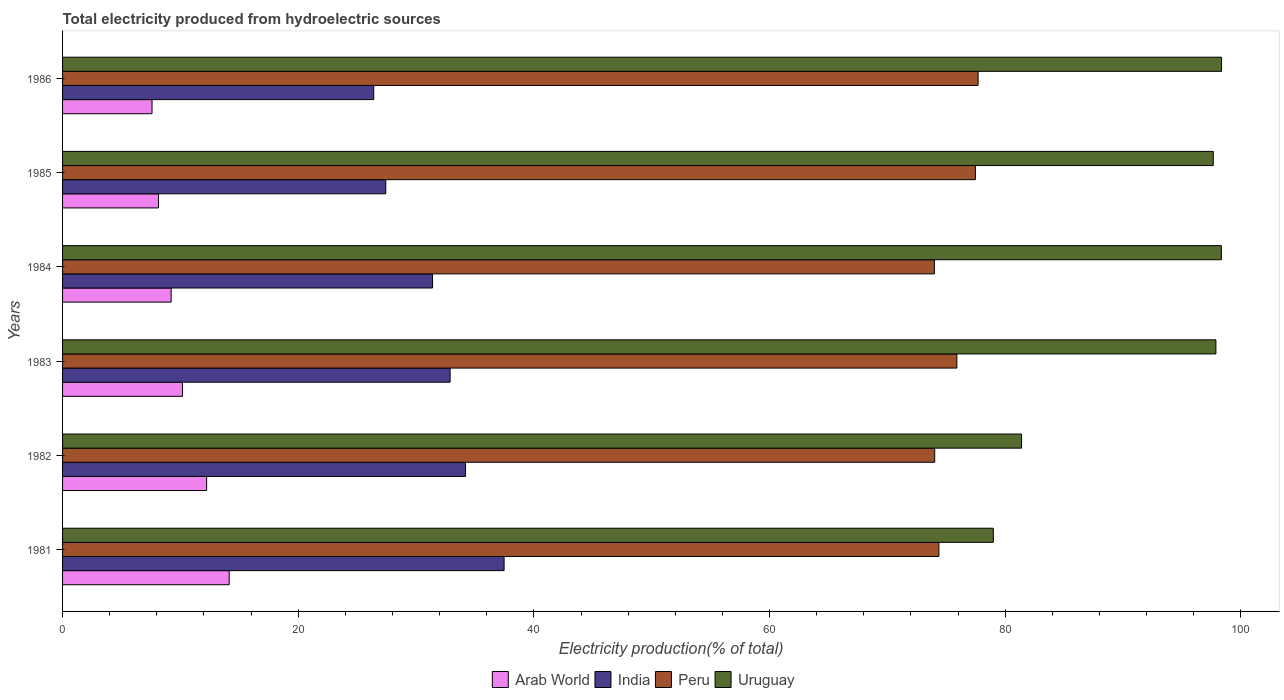How many different coloured bars are there?
Offer a terse response. 4. Are the number of bars per tick equal to the number of legend labels?
Offer a terse response. Yes. How many bars are there on the 1st tick from the top?
Give a very brief answer. 4. What is the total electricity produced in Peru in 1982?
Offer a very short reply. 74.01. Across all years, what is the maximum total electricity produced in Peru?
Provide a succinct answer. 77.7. Across all years, what is the minimum total electricity produced in Arab World?
Your answer should be very brief. 7.59. In which year was the total electricity produced in Uruguay minimum?
Your response must be concise. 1981. What is the total total electricity produced in India in the graph?
Make the answer very short. 189.79. What is the difference between the total electricity produced in India in 1983 and that in 1985?
Offer a very short reply. 5.46. What is the difference between the total electricity produced in India in 1985 and the total electricity produced in Uruguay in 1984?
Give a very brief answer. -70.91. What is the average total electricity produced in India per year?
Provide a succinct answer. 31.63. In the year 1984, what is the difference between the total electricity produced in Peru and total electricity produced in India?
Give a very brief answer. 42.59. What is the ratio of the total electricity produced in Arab World in 1981 to that in 1983?
Your answer should be compact. 1.39. Is the difference between the total electricity produced in Peru in 1982 and 1985 greater than the difference between the total electricity produced in India in 1982 and 1985?
Offer a terse response. No. What is the difference between the highest and the second highest total electricity produced in India?
Provide a succinct answer. 3.27. What is the difference between the highest and the lowest total electricity produced in Arab World?
Provide a succinct answer. 6.55. In how many years, is the total electricity produced in Peru greater than the average total electricity produced in Peru taken over all years?
Your answer should be compact. 3. Is it the case that in every year, the sum of the total electricity produced in Arab World and total electricity produced in India is greater than the sum of total electricity produced in Peru and total electricity produced in Uruguay?
Offer a terse response. No. Is it the case that in every year, the sum of the total electricity produced in Peru and total electricity produced in India is greater than the total electricity produced in Arab World?
Make the answer very short. Yes. What is the difference between two consecutive major ticks on the X-axis?
Provide a short and direct response. 20. Does the graph contain grids?
Your answer should be very brief. No. Where does the legend appear in the graph?
Your response must be concise. Bottom center. How are the legend labels stacked?
Provide a succinct answer. Horizontal. What is the title of the graph?
Your answer should be compact. Total electricity produced from hydroelectric sources. What is the Electricity production(% of total) in Arab World in 1981?
Offer a terse response. 14.14. What is the Electricity production(% of total) in India in 1981?
Provide a succinct answer. 37.47. What is the Electricity production(% of total) of Peru in 1981?
Make the answer very short. 74.37. What is the Electricity production(% of total) in Uruguay in 1981?
Ensure brevity in your answer.  78.99. What is the Electricity production(% of total) of Arab World in 1982?
Your answer should be compact. 12.23. What is the Electricity production(% of total) of India in 1982?
Give a very brief answer. 34.2. What is the Electricity production(% of total) in Peru in 1982?
Ensure brevity in your answer.  74.01. What is the Electricity production(% of total) of Uruguay in 1982?
Your answer should be compact. 81.38. What is the Electricity production(% of total) of Arab World in 1983?
Your answer should be very brief. 10.17. What is the Electricity production(% of total) of India in 1983?
Your answer should be compact. 32.89. What is the Electricity production(% of total) in Peru in 1983?
Your response must be concise. 75.89. What is the Electricity production(% of total) in Uruguay in 1983?
Offer a terse response. 97.88. What is the Electricity production(% of total) in Arab World in 1984?
Offer a very short reply. 9.22. What is the Electricity production(% of total) of India in 1984?
Provide a short and direct response. 31.4. What is the Electricity production(% of total) of Peru in 1984?
Give a very brief answer. 73.99. What is the Electricity production(% of total) in Uruguay in 1984?
Your response must be concise. 98.34. What is the Electricity production(% of total) of Arab World in 1985?
Keep it short and to the point. 8.14. What is the Electricity production(% of total) of India in 1985?
Make the answer very short. 27.43. What is the Electricity production(% of total) of Peru in 1985?
Make the answer very short. 77.47. What is the Electricity production(% of total) in Uruguay in 1985?
Keep it short and to the point. 97.65. What is the Electricity production(% of total) in Arab World in 1986?
Provide a short and direct response. 7.59. What is the Electricity production(% of total) in India in 1986?
Offer a very short reply. 26.41. What is the Electricity production(% of total) of Peru in 1986?
Offer a very short reply. 77.7. What is the Electricity production(% of total) of Uruguay in 1986?
Provide a succinct answer. 98.35. Across all years, what is the maximum Electricity production(% of total) of Arab World?
Make the answer very short. 14.14. Across all years, what is the maximum Electricity production(% of total) of India?
Ensure brevity in your answer.  37.47. Across all years, what is the maximum Electricity production(% of total) of Peru?
Provide a short and direct response. 77.7. Across all years, what is the maximum Electricity production(% of total) of Uruguay?
Give a very brief answer. 98.35. Across all years, what is the minimum Electricity production(% of total) in Arab World?
Ensure brevity in your answer.  7.59. Across all years, what is the minimum Electricity production(% of total) of India?
Your answer should be very brief. 26.41. Across all years, what is the minimum Electricity production(% of total) in Peru?
Your answer should be very brief. 73.99. Across all years, what is the minimum Electricity production(% of total) of Uruguay?
Your answer should be very brief. 78.99. What is the total Electricity production(% of total) of Arab World in the graph?
Your answer should be compact. 61.49. What is the total Electricity production(% of total) in India in the graph?
Offer a terse response. 189.79. What is the total Electricity production(% of total) in Peru in the graph?
Give a very brief answer. 453.42. What is the total Electricity production(% of total) of Uruguay in the graph?
Keep it short and to the point. 552.6. What is the difference between the Electricity production(% of total) of Arab World in 1981 and that in 1982?
Your response must be concise. 1.91. What is the difference between the Electricity production(% of total) of India in 1981 and that in 1982?
Make the answer very short. 3.27. What is the difference between the Electricity production(% of total) in Peru in 1981 and that in 1982?
Make the answer very short. 0.35. What is the difference between the Electricity production(% of total) in Uruguay in 1981 and that in 1982?
Offer a very short reply. -2.4. What is the difference between the Electricity production(% of total) in Arab World in 1981 and that in 1983?
Keep it short and to the point. 3.97. What is the difference between the Electricity production(% of total) of India in 1981 and that in 1983?
Your answer should be compact. 4.58. What is the difference between the Electricity production(% of total) in Peru in 1981 and that in 1983?
Provide a succinct answer. -1.53. What is the difference between the Electricity production(% of total) of Uruguay in 1981 and that in 1983?
Make the answer very short. -18.89. What is the difference between the Electricity production(% of total) of Arab World in 1981 and that in 1984?
Offer a very short reply. 4.93. What is the difference between the Electricity production(% of total) of India in 1981 and that in 1984?
Make the answer very short. 6.07. What is the difference between the Electricity production(% of total) in Peru in 1981 and that in 1984?
Keep it short and to the point. 0.38. What is the difference between the Electricity production(% of total) of Uruguay in 1981 and that in 1984?
Give a very brief answer. -19.35. What is the difference between the Electricity production(% of total) in Arab World in 1981 and that in 1985?
Make the answer very short. 6. What is the difference between the Electricity production(% of total) of India in 1981 and that in 1985?
Provide a short and direct response. 10.04. What is the difference between the Electricity production(% of total) in Peru in 1981 and that in 1985?
Your answer should be compact. -3.1. What is the difference between the Electricity production(% of total) in Uruguay in 1981 and that in 1985?
Your answer should be very brief. -18.67. What is the difference between the Electricity production(% of total) in Arab World in 1981 and that in 1986?
Ensure brevity in your answer.  6.55. What is the difference between the Electricity production(% of total) of India in 1981 and that in 1986?
Offer a very short reply. 11.06. What is the difference between the Electricity production(% of total) of Peru in 1981 and that in 1986?
Your answer should be compact. -3.33. What is the difference between the Electricity production(% of total) in Uruguay in 1981 and that in 1986?
Your answer should be compact. -19.37. What is the difference between the Electricity production(% of total) of Arab World in 1982 and that in 1983?
Your answer should be compact. 2.05. What is the difference between the Electricity production(% of total) in India in 1982 and that in 1983?
Keep it short and to the point. 1.31. What is the difference between the Electricity production(% of total) in Peru in 1982 and that in 1983?
Offer a terse response. -1.88. What is the difference between the Electricity production(% of total) in Uruguay in 1982 and that in 1983?
Give a very brief answer. -16.49. What is the difference between the Electricity production(% of total) of Arab World in 1982 and that in 1984?
Give a very brief answer. 3.01. What is the difference between the Electricity production(% of total) of India in 1982 and that in 1984?
Ensure brevity in your answer.  2.8. What is the difference between the Electricity production(% of total) of Peru in 1982 and that in 1984?
Your answer should be compact. 0.03. What is the difference between the Electricity production(% of total) of Uruguay in 1982 and that in 1984?
Offer a very short reply. -16.96. What is the difference between the Electricity production(% of total) in Arab World in 1982 and that in 1985?
Your answer should be very brief. 4.09. What is the difference between the Electricity production(% of total) in India in 1982 and that in 1985?
Offer a very short reply. 6.77. What is the difference between the Electricity production(% of total) of Peru in 1982 and that in 1985?
Your answer should be compact. -3.45. What is the difference between the Electricity production(% of total) in Uruguay in 1982 and that in 1985?
Provide a short and direct response. -16.27. What is the difference between the Electricity production(% of total) of Arab World in 1982 and that in 1986?
Keep it short and to the point. 4.63. What is the difference between the Electricity production(% of total) of India in 1982 and that in 1986?
Your answer should be compact. 7.79. What is the difference between the Electricity production(% of total) in Peru in 1982 and that in 1986?
Make the answer very short. -3.68. What is the difference between the Electricity production(% of total) in Uruguay in 1982 and that in 1986?
Give a very brief answer. -16.97. What is the difference between the Electricity production(% of total) in Arab World in 1983 and that in 1984?
Provide a succinct answer. 0.96. What is the difference between the Electricity production(% of total) of India in 1983 and that in 1984?
Provide a short and direct response. 1.49. What is the difference between the Electricity production(% of total) in Peru in 1983 and that in 1984?
Your response must be concise. 1.91. What is the difference between the Electricity production(% of total) of Uruguay in 1983 and that in 1984?
Your response must be concise. -0.46. What is the difference between the Electricity production(% of total) in Arab World in 1983 and that in 1985?
Keep it short and to the point. 2.03. What is the difference between the Electricity production(% of total) in India in 1983 and that in 1985?
Give a very brief answer. 5.46. What is the difference between the Electricity production(% of total) of Peru in 1983 and that in 1985?
Offer a terse response. -1.57. What is the difference between the Electricity production(% of total) of Uruguay in 1983 and that in 1985?
Ensure brevity in your answer.  0.22. What is the difference between the Electricity production(% of total) of Arab World in 1983 and that in 1986?
Provide a short and direct response. 2.58. What is the difference between the Electricity production(% of total) of India in 1983 and that in 1986?
Keep it short and to the point. 6.48. What is the difference between the Electricity production(% of total) of Peru in 1983 and that in 1986?
Your answer should be very brief. -1.8. What is the difference between the Electricity production(% of total) in Uruguay in 1983 and that in 1986?
Provide a succinct answer. -0.48. What is the difference between the Electricity production(% of total) of Arab World in 1984 and that in 1985?
Make the answer very short. 1.08. What is the difference between the Electricity production(% of total) of India in 1984 and that in 1985?
Provide a short and direct response. 3.97. What is the difference between the Electricity production(% of total) of Peru in 1984 and that in 1985?
Your answer should be very brief. -3.48. What is the difference between the Electricity production(% of total) in Uruguay in 1984 and that in 1985?
Offer a terse response. 0.69. What is the difference between the Electricity production(% of total) of Arab World in 1984 and that in 1986?
Offer a terse response. 1.62. What is the difference between the Electricity production(% of total) in India in 1984 and that in 1986?
Offer a terse response. 4.99. What is the difference between the Electricity production(% of total) of Peru in 1984 and that in 1986?
Your answer should be very brief. -3.71. What is the difference between the Electricity production(% of total) in Uruguay in 1984 and that in 1986?
Give a very brief answer. -0.02. What is the difference between the Electricity production(% of total) of Arab World in 1985 and that in 1986?
Ensure brevity in your answer.  0.55. What is the difference between the Electricity production(% of total) of India in 1985 and that in 1986?
Your response must be concise. 1.02. What is the difference between the Electricity production(% of total) of Peru in 1985 and that in 1986?
Provide a succinct answer. -0.23. What is the difference between the Electricity production(% of total) in Uruguay in 1985 and that in 1986?
Make the answer very short. -0.7. What is the difference between the Electricity production(% of total) of Arab World in 1981 and the Electricity production(% of total) of India in 1982?
Give a very brief answer. -20.06. What is the difference between the Electricity production(% of total) of Arab World in 1981 and the Electricity production(% of total) of Peru in 1982?
Offer a very short reply. -59.87. What is the difference between the Electricity production(% of total) in Arab World in 1981 and the Electricity production(% of total) in Uruguay in 1982?
Offer a very short reply. -67.24. What is the difference between the Electricity production(% of total) of India in 1981 and the Electricity production(% of total) of Peru in 1982?
Your response must be concise. -36.54. What is the difference between the Electricity production(% of total) of India in 1981 and the Electricity production(% of total) of Uruguay in 1982?
Give a very brief answer. -43.91. What is the difference between the Electricity production(% of total) in Peru in 1981 and the Electricity production(% of total) in Uruguay in 1982?
Provide a short and direct response. -7.02. What is the difference between the Electricity production(% of total) of Arab World in 1981 and the Electricity production(% of total) of India in 1983?
Offer a very short reply. -18.75. What is the difference between the Electricity production(% of total) in Arab World in 1981 and the Electricity production(% of total) in Peru in 1983?
Keep it short and to the point. -61.75. What is the difference between the Electricity production(% of total) of Arab World in 1981 and the Electricity production(% of total) of Uruguay in 1983?
Offer a terse response. -83.74. What is the difference between the Electricity production(% of total) of India in 1981 and the Electricity production(% of total) of Peru in 1983?
Ensure brevity in your answer.  -38.42. What is the difference between the Electricity production(% of total) of India in 1981 and the Electricity production(% of total) of Uruguay in 1983?
Offer a very short reply. -60.41. What is the difference between the Electricity production(% of total) of Peru in 1981 and the Electricity production(% of total) of Uruguay in 1983?
Offer a very short reply. -23.51. What is the difference between the Electricity production(% of total) of Arab World in 1981 and the Electricity production(% of total) of India in 1984?
Your answer should be compact. -17.26. What is the difference between the Electricity production(% of total) in Arab World in 1981 and the Electricity production(% of total) in Peru in 1984?
Your answer should be compact. -59.84. What is the difference between the Electricity production(% of total) of Arab World in 1981 and the Electricity production(% of total) of Uruguay in 1984?
Provide a succinct answer. -84.2. What is the difference between the Electricity production(% of total) of India in 1981 and the Electricity production(% of total) of Peru in 1984?
Offer a terse response. -36.52. What is the difference between the Electricity production(% of total) of India in 1981 and the Electricity production(% of total) of Uruguay in 1984?
Your response must be concise. -60.87. What is the difference between the Electricity production(% of total) in Peru in 1981 and the Electricity production(% of total) in Uruguay in 1984?
Make the answer very short. -23.97. What is the difference between the Electricity production(% of total) in Arab World in 1981 and the Electricity production(% of total) in India in 1985?
Keep it short and to the point. -13.29. What is the difference between the Electricity production(% of total) of Arab World in 1981 and the Electricity production(% of total) of Peru in 1985?
Your response must be concise. -63.33. What is the difference between the Electricity production(% of total) in Arab World in 1981 and the Electricity production(% of total) in Uruguay in 1985?
Keep it short and to the point. -83.51. What is the difference between the Electricity production(% of total) of India in 1981 and the Electricity production(% of total) of Peru in 1985?
Your response must be concise. -40. What is the difference between the Electricity production(% of total) in India in 1981 and the Electricity production(% of total) in Uruguay in 1985?
Provide a succinct answer. -60.18. What is the difference between the Electricity production(% of total) of Peru in 1981 and the Electricity production(% of total) of Uruguay in 1985?
Your answer should be compact. -23.29. What is the difference between the Electricity production(% of total) in Arab World in 1981 and the Electricity production(% of total) in India in 1986?
Provide a short and direct response. -12.26. What is the difference between the Electricity production(% of total) in Arab World in 1981 and the Electricity production(% of total) in Peru in 1986?
Ensure brevity in your answer.  -63.55. What is the difference between the Electricity production(% of total) of Arab World in 1981 and the Electricity production(% of total) of Uruguay in 1986?
Offer a very short reply. -84.21. What is the difference between the Electricity production(% of total) of India in 1981 and the Electricity production(% of total) of Peru in 1986?
Ensure brevity in your answer.  -40.23. What is the difference between the Electricity production(% of total) of India in 1981 and the Electricity production(% of total) of Uruguay in 1986?
Make the answer very short. -60.89. What is the difference between the Electricity production(% of total) in Peru in 1981 and the Electricity production(% of total) in Uruguay in 1986?
Keep it short and to the point. -23.99. What is the difference between the Electricity production(% of total) of Arab World in 1982 and the Electricity production(% of total) of India in 1983?
Ensure brevity in your answer.  -20.66. What is the difference between the Electricity production(% of total) in Arab World in 1982 and the Electricity production(% of total) in Peru in 1983?
Keep it short and to the point. -63.67. What is the difference between the Electricity production(% of total) of Arab World in 1982 and the Electricity production(% of total) of Uruguay in 1983?
Make the answer very short. -85.65. What is the difference between the Electricity production(% of total) in India in 1982 and the Electricity production(% of total) in Peru in 1983?
Your answer should be compact. -41.7. What is the difference between the Electricity production(% of total) of India in 1982 and the Electricity production(% of total) of Uruguay in 1983?
Keep it short and to the point. -63.68. What is the difference between the Electricity production(% of total) of Peru in 1982 and the Electricity production(% of total) of Uruguay in 1983?
Your response must be concise. -23.86. What is the difference between the Electricity production(% of total) of Arab World in 1982 and the Electricity production(% of total) of India in 1984?
Provide a succinct answer. -19.17. What is the difference between the Electricity production(% of total) of Arab World in 1982 and the Electricity production(% of total) of Peru in 1984?
Offer a terse response. -61.76. What is the difference between the Electricity production(% of total) in Arab World in 1982 and the Electricity production(% of total) in Uruguay in 1984?
Make the answer very short. -86.11. What is the difference between the Electricity production(% of total) of India in 1982 and the Electricity production(% of total) of Peru in 1984?
Keep it short and to the point. -39.79. What is the difference between the Electricity production(% of total) in India in 1982 and the Electricity production(% of total) in Uruguay in 1984?
Offer a terse response. -64.14. What is the difference between the Electricity production(% of total) of Peru in 1982 and the Electricity production(% of total) of Uruguay in 1984?
Make the answer very short. -24.33. What is the difference between the Electricity production(% of total) of Arab World in 1982 and the Electricity production(% of total) of India in 1985?
Provide a short and direct response. -15.2. What is the difference between the Electricity production(% of total) in Arab World in 1982 and the Electricity production(% of total) in Peru in 1985?
Your answer should be compact. -65.24. What is the difference between the Electricity production(% of total) in Arab World in 1982 and the Electricity production(% of total) in Uruguay in 1985?
Give a very brief answer. -85.43. What is the difference between the Electricity production(% of total) in India in 1982 and the Electricity production(% of total) in Peru in 1985?
Your answer should be very brief. -43.27. What is the difference between the Electricity production(% of total) in India in 1982 and the Electricity production(% of total) in Uruguay in 1985?
Provide a short and direct response. -63.46. What is the difference between the Electricity production(% of total) in Peru in 1982 and the Electricity production(% of total) in Uruguay in 1985?
Your answer should be compact. -23.64. What is the difference between the Electricity production(% of total) in Arab World in 1982 and the Electricity production(% of total) in India in 1986?
Your answer should be compact. -14.18. What is the difference between the Electricity production(% of total) in Arab World in 1982 and the Electricity production(% of total) in Peru in 1986?
Offer a very short reply. -65.47. What is the difference between the Electricity production(% of total) of Arab World in 1982 and the Electricity production(% of total) of Uruguay in 1986?
Provide a succinct answer. -86.13. What is the difference between the Electricity production(% of total) in India in 1982 and the Electricity production(% of total) in Peru in 1986?
Ensure brevity in your answer.  -43.5. What is the difference between the Electricity production(% of total) in India in 1982 and the Electricity production(% of total) in Uruguay in 1986?
Make the answer very short. -64.16. What is the difference between the Electricity production(% of total) of Peru in 1982 and the Electricity production(% of total) of Uruguay in 1986?
Ensure brevity in your answer.  -24.34. What is the difference between the Electricity production(% of total) of Arab World in 1983 and the Electricity production(% of total) of India in 1984?
Your answer should be compact. -21.22. What is the difference between the Electricity production(% of total) of Arab World in 1983 and the Electricity production(% of total) of Peru in 1984?
Ensure brevity in your answer.  -63.81. What is the difference between the Electricity production(% of total) of Arab World in 1983 and the Electricity production(% of total) of Uruguay in 1984?
Ensure brevity in your answer.  -88.17. What is the difference between the Electricity production(% of total) in India in 1983 and the Electricity production(% of total) in Peru in 1984?
Keep it short and to the point. -41.1. What is the difference between the Electricity production(% of total) of India in 1983 and the Electricity production(% of total) of Uruguay in 1984?
Provide a short and direct response. -65.45. What is the difference between the Electricity production(% of total) of Peru in 1983 and the Electricity production(% of total) of Uruguay in 1984?
Offer a very short reply. -22.45. What is the difference between the Electricity production(% of total) of Arab World in 1983 and the Electricity production(% of total) of India in 1985?
Provide a short and direct response. -17.25. What is the difference between the Electricity production(% of total) of Arab World in 1983 and the Electricity production(% of total) of Peru in 1985?
Give a very brief answer. -67.29. What is the difference between the Electricity production(% of total) in Arab World in 1983 and the Electricity production(% of total) in Uruguay in 1985?
Provide a succinct answer. -87.48. What is the difference between the Electricity production(% of total) in India in 1983 and the Electricity production(% of total) in Peru in 1985?
Your response must be concise. -44.58. What is the difference between the Electricity production(% of total) of India in 1983 and the Electricity production(% of total) of Uruguay in 1985?
Your response must be concise. -64.77. What is the difference between the Electricity production(% of total) in Peru in 1983 and the Electricity production(% of total) in Uruguay in 1985?
Your answer should be very brief. -21.76. What is the difference between the Electricity production(% of total) in Arab World in 1983 and the Electricity production(% of total) in India in 1986?
Keep it short and to the point. -16.23. What is the difference between the Electricity production(% of total) of Arab World in 1983 and the Electricity production(% of total) of Peru in 1986?
Your answer should be compact. -67.52. What is the difference between the Electricity production(% of total) in Arab World in 1983 and the Electricity production(% of total) in Uruguay in 1986?
Your response must be concise. -88.18. What is the difference between the Electricity production(% of total) of India in 1983 and the Electricity production(% of total) of Peru in 1986?
Your answer should be very brief. -44.81. What is the difference between the Electricity production(% of total) in India in 1983 and the Electricity production(% of total) in Uruguay in 1986?
Offer a terse response. -65.47. What is the difference between the Electricity production(% of total) of Peru in 1983 and the Electricity production(% of total) of Uruguay in 1986?
Keep it short and to the point. -22.46. What is the difference between the Electricity production(% of total) in Arab World in 1984 and the Electricity production(% of total) in India in 1985?
Make the answer very short. -18.21. What is the difference between the Electricity production(% of total) of Arab World in 1984 and the Electricity production(% of total) of Peru in 1985?
Provide a short and direct response. -68.25. What is the difference between the Electricity production(% of total) of Arab World in 1984 and the Electricity production(% of total) of Uruguay in 1985?
Keep it short and to the point. -88.44. What is the difference between the Electricity production(% of total) of India in 1984 and the Electricity production(% of total) of Peru in 1985?
Your answer should be compact. -46.07. What is the difference between the Electricity production(% of total) of India in 1984 and the Electricity production(% of total) of Uruguay in 1985?
Your answer should be compact. -66.26. What is the difference between the Electricity production(% of total) of Peru in 1984 and the Electricity production(% of total) of Uruguay in 1985?
Make the answer very short. -23.67. What is the difference between the Electricity production(% of total) of Arab World in 1984 and the Electricity production(% of total) of India in 1986?
Offer a very short reply. -17.19. What is the difference between the Electricity production(% of total) in Arab World in 1984 and the Electricity production(% of total) in Peru in 1986?
Offer a terse response. -68.48. What is the difference between the Electricity production(% of total) in Arab World in 1984 and the Electricity production(% of total) in Uruguay in 1986?
Give a very brief answer. -89.14. What is the difference between the Electricity production(% of total) in India in 1984 and the Electricity production(% of total) in Peru in 1986?
Your answer should be compact. -46.3. What is the difference between the Electricity production(% of total) of India in 1984 and the Electricity production(% of total) of Uruguay in 1986?
Offer a terse response. -66.96. What is the difference between the Electricity production(% of total) of Peru in 1984 and the Electricity production(% of total) of Uruguay in 1986?
Offer a very short reply. -24.37. What is the difference between the Electricity production(% of total) of Arab World in 1985 and the Electricity production(% of total) of India in 1986?
Provide a short and direct response. -18.27. What is the difference between the Electricity production(% of total) in Arab World in 1985 and the Electricity production(% of total) in Peru in 1986?
Keep it short and to the point. -69.56. What is the difference between the Electricity production(% of total) in Arab World in 1985 and the Electricity production(% of total) in Uruguay in 1986?
Provide a short and direct response. -90.21. What is the difference between the Electricity production(% of total) of India in 1985 and the Electricity production(% of total) of Peru in 1986?
Your answer should be very brief. -50.27. What is the difference between the Electricity production(% of total) of India in 1985 and the Electricity production(% of total) of Uruguay in 1986?
Keep it short and to the point. -70.93. What is the difference between the Electricity production(% of total) in Peru in 1985 and the Electricity production(% of total) in Uruguay in 1986?
Your answer should be very brief. -20.89. What is the average Electricity production(% of total) in Arab World per year?
Your answer should be very brief. 10.25. What is the average Electricity production(% of total) of India per year?
Keep it short and to the point. 31.63. What is the average Electricity production(% of total) in Peru per year?
Your answer should be very brief. 75.57. What is the average Electricity production(% of total) of Uruguay per year?
Your response must be concise. 92.1. In the year 1981, what is the difference between the Electricity production(% of total) in Arab World and Electricity production(% of total) in India?
Give a very brief answer. -23.33. In the year 1981, what is the difference between the Electricity production(% of total) in Arab World and Electricity production(% of total) in Peru?
Make the answer very short. -60.23. In the year 1981, what is the difference between the Electricity production(% of total) of Arab World and Electricity production(% of total) of Uruguay?
Keep it short and to the point. -64.85. In the year 1981, what is the difference between the Electricity production(% of total) of India and Electricity production(% of total) of Peru?
Your answer should be compact. -36.9. In the year 1981, what is the difference between the Electricity production(% of total) in India and Electricity production(% of total) in Uruguay?
Keep it short and to the point. -41.52. In the year 1981, what is the difference between the Electricity production(% of total) of Peru and Electricity production(% of total) of Uruguay?
Offer a very short reply. -4.62. In the year 1982, what is the difference between the Electricity production(% of total) of Arab World and Electricity production(% of total) of India?
Give a very brief answer. -21.97. In the year 1982, what is the difference between the Electricity production(% of total) of Arab World and Electricity production(% of total) of Peru?
Your answer should be very brief. -61.79. In the year 1982, what is the difference between the Electricity production(% of total) of Arab World and Electricity production(% of total) of Uruguay?
Your answer should be compact. -69.16. In the year 1982, what is the difference between the Electricity production(% of total) in India and Electricity production(% of total) in Peru?
Your answer should be compact. -39.81. In the year 1982, what is the difference between the Electricity production(% of total) of India and Electricity production(% of total) of Uruguay?
Ensure brevity in your answer.  -47.19. In the year 1982, what is the difference between the Electricity production(% of total) of Peru and Electricity production(% of total) of Uruguay?
Your answer should be compact. -7.37. In the year 1983, what is the difference between the Electricity production(% of total) in Arab World and Electricity production(% of total) in India?
Your answer should be very brief. -22.71. In the year 1983, what is the difference between the Electricity production(% of total) of Arab World and Electricity production(% of total) of Peru?
Your answer should be very brief. -65.72. In the year 1983, what is the difference between the Electricity production(% of total) in Arab World and Electricity production(% of total) in Uruguay?
Provide a short and direct response. -87.7. In the year 1983, what is the difference between the Electricity production(% of total) in India and Electricity production(% of total) in Peru?
Make the answer very short. -43.01. In the year 1983, what is the difference between the Electricity production(% of total) in India and Electricity production(% of total) in Uruguay?
Offer a very short reply. -64.99. In the year 1983, what is the difference between the Electricity production(% of total) in Peru and Electricity production(% of total) in Uruguay?
Provide a succinct answer. -21.98. In the year 1984, what is the difference between the Electricity production(% of total) in Arab World and Electricity production(% of total) in India?
Your answer should be compact. -22.18. In the year 1984, what is the difference between the Electricity production(% of total) of Arab World and Electricity production(% of total) of Peru?
Provide a succinct answer. -64.77. In the year 1984, what is the difference between the Electricity production(% of total) of Arab World and Electricity production(% of total) of Uruguay?
Keep it short and to the point. -89.12. In the year 1984, what is the difference between the Electricity production(% of total) in India and Electricity production(% of total) in Peru?
Offer a very short reply. -42.59. In the year 1984, what is the difference between the Electricity production(% of total) of India and Electricity production(% of total) of Uruguay?
Give a very brief answer. -66.94. In the year 1984, what is the difference between the Electricity production(% of total) in Peru and Electricity production(% of total) in Uruguay?
Your response must be concise. -24.35. In the year 1985, what is the difference between the Electricity production(% of total) of Arab World and Electricity production(% of total) of India?
Offer a very short reply. -19.29. In the year 1985, what is the difference between the Electricity production(% of total) in Arab World and Electricity production(% of total) in Peru?
Offer a terse response. -69.33. In the year 1985, what is the difference between the Electricity production(% of total) in Arab World and Electricity production(% of total) in Uruguay?
Give a very brief answer. -89.51. In the year 1985, what is the difference between the Electricity production(% of total) in India and Electricity production(% of total) in Peru?
Make the answer very short. -50.04. In the year 1985, what is the difference between the Electricity production(% of total) in India and Electricity production(% of total) in Uruguay?
Your answer should be compact. -70.23. In the year 1985, what is the difference between the Electricity production(% of total) in Peru and Electricity production(% of total) in Uruguay?
Offer a terse response. -20.19. In the year 1986, what is the difference between the Electricity production(% of total) in Arab World and Electricity production(% of total) in India?
Give a very brief answer. -18.81. In the year 1986, what is the difference between the Electricity production(% of total) in Arab World and Electricity production(% of total) in Peru?
Offer a very short reply. -70.1. In the year 1986, what is the difference between the Electricity production(% of total) of Arab World and Electricity production(% of total) of Uruguay?
Offer a terse response. -90.76. In the year 1986, what is the difference between the Electricity production(% of total) of India and Electricity production(% of total) of Peru?
Give a very brief answer. -51.29. In the year 1986, what is the difference between the Electricity production(% of total) of India and Electricity production(% of total) of Uruguay?
Your response must be concise. -71.95. In the year 1986, what is the difference between the Electricity production(% of total) of Peru and Electricity production(% of total) of Uruguay?
Provide a succinct answer. -20.66. What is the ratio of the Electricity production(% of total) of Arab World in 1981 to that in 1982?
Provide a short and direct response. 1.16. What is the ratio of the Electricity production(% of total) in India in 1981 to that in 1982?
Provide a succinct answer. 1.1. What is the ratio of the Electricity production(% of total) in Peru in 1981 to that in 1982?
Provide a succinct answer. 1. What is the ratio of the Electricity production(% of total) of Uruguay in 1981 to that in 1982?
Ensure brevity in your answer.  0.97. What is the ratio of the Electricity production(% of total) in Arab World in 1981 to that in 1983?
Your answer should be compact. 1.39. What is the ratio of the Electricity production(% of total) of India in 1981 to that in 1983?
Ensure brevity in your answer.  1.14. What is the ratio of the Electricity production(% of total) of Peru in 1981 to that in 1983?
Ensure brevity in your answer.  0.98. What is the ratio of the Electricity production(% of total) in Uruguay in 1981 to that in 1983?
Offer a terse response. 0.81. What is the ratio of the Electricity production(% of total) of Arab World in 1981 to that in 1984?
Your response must be concise. 1.53. What is the ratio of the Electricity production(% of total) of India in 1981 to that in 1984?
Make the answer very short. 1.19. What is the ratio of the Electricity production(% of total) in Uruguay in 1981 to that in 1984?
Your response must be concise. 0.8. What is the ratio of the Electricity production(% of total) of Arab World in 1981 to that in 1985?
Your response must be concise. 1.74. What is the ratio of the Electricity production(% of total) in India in 1981 to that in 1985?
Provide a succinct answer. 1.37. What is the ratio of the Electricity production(% of total) of Uruguay in 1981 to that in 1985?
Provide a succinct answer. 0.81. What is the ratio of the Electricity production(% of total) in Arab World in 1981 to that in 1986?
Offer a very short reply. 1.86. What is the ratio of the Electricity production(% of total) in India in 1981 to that in 1986?
Keep it short and to the point. 1.42. What is the ratio of the Electricity production(% of total) of Peru in 1981 to that in 1986?
Make the answer very short. 0.96. What is the ratio of the Electricity production(% of total) of Uruguay in 1981 to that in 1986?
Provide a short and direct response. 0.8. What is the ratio of the Electricity production(% of total) of Arab World in 1982 to that in 1983?
Keep it short and to the point. 1.2. What is the ratio of the Electricity production(% of total) in India in 1982 to that in 1983?
Provide a succinct answer. 1.04. What is the ratio of the Electricity production(% of total) of Peru in 1982 to that in 1983?
Your answer should be compact. 0.98. What is the ratio of the Electricity production(% of total) of Uruguay in 1982 to that in 1983?
Ensure brevity in your answer.  0.83. What is the ratio of the Electricity production(% of total) of Arab World in 1982 to that in 1984?
Provide a short and direct response. 1.33. What is the ratio of the Electricity production(% of total) of India in 1982 to that in 1984?
Offer a terse response. 1.09. What is the ratio of the Electricity production(% of total) of Uruguay in 1982 to that in 1984?
Your answer should be compact. 0.83. What is the ratio of the Electricity production(% of total) of Arab World in 1982 to that in 1985?
Provide a succinct answer. 1.5. What is the ratio of the Electricity production(% of total) of India in 1982 to that in 1985?
Make the answer very short. 1.25. What is the ratio of the Electricity production(% of total) of Peru in 1982 to that in 1985?
Provide a succinct answer. 0.96. What is the ratio of the Electricity production(% of total) of Uruguay in 1982 to that in 1985?
Offer a terse response. 0.83. What is the ratio of the Electricity production(% of total) of Arab World in 1982 to that in 1986?
Your response must be concise. 1.61. What is the ratio of the Electricity production(% of total) of India in 1982 to that in 1986?
Ensure brevity in your answer.  1.3. What is the ratio of the Electricity production(% of total) of Peru in 1982 to that in 1986?
Offer a terse response. 0.95. What is the ratio of the Electricity production(% of total) in Uruguay in 1982 to that in 1986?
Offer a terse response. 0.83. What is the ratio of the Electricity production(% of total) of Arab World in 1983 to that in 1984?
Ensure brevity in your answer.  1.1. What is the ratio of the Electricity production(% of total) in India in 1983 to that in 1984?
Provide a succinct answer. 1.05. What is the ratio of the Electricity production(% of total) of Peru in 1983 to that in 1984?
Your response must be concise. 1.03. What is the ratio of the Electricity production(% of total) in Arab World in 1983 to that in 1985?
Your answer should be compact. 1.25. What is the ratio of the Electricity production(% of total) in India in 1983 to that in 1985?
Keep it short and to the point. 1.2. What is the ratio of the Electricity production(% of total) of Peru in 1983 to that in 1985?
Provide a short and direct response. 0.98. What is the ratio of the Electricity production(% of total) of Arab World in 1983 to that in 1986?
Offer a very short reply. 1.34. What is the ratio of the Electricity production(% of total) of India in 1983 to that in 1986?
Make the answer very short. 1.25. What is the ratio of the Electricity production(% of total) in Peru in 1983 to that in 1986?
Give a very brief answer. 0.98. What is the ratio of the Electricity production(% of total) of Uruguay in 1983 to that in 1986?
Offer a very short reply. 1. What is the ratio of the Electricity production(% of total) of Arab World in 1984 to that in 1985?
Keep it short and to the point. 1.13. What is the ratio of the Electricity production(% of total) in India in 1984 to that in 1985?
Provide a succinct answer. 1.14. What is the ratio of the Electricity production(% of total) in Peru in 1984 to that in 1985?
Your answer should be very brief. 0.96. What is the ratio of the Electricity production(% of total) in Uruguay in 1984 to that in 1985?
Your response must be concise. 1.01. What is the ratio of the Electricity production(% of total) in Arab World in 1984 to that in 1986?
Provide a short and direct response. 1.21. What is the ratio of the Electricity production(% of total) in India in 1984 to that in 1986?
Offer a very short reply. 1.19. What is the ratio of the Electricity production(% of total) in Peru in 1984 to that in 1986?
Your answer should be compact. 0.95. What is the ratio of the Electricity production(% of total) of Arab World in 1985 to that in 1986?
Provide a succinct answer. 1.07. What is the ratio of the Electricity production(% of total) in India in 1985 to that in 1986?
Your answer should be compact. 1.04. What is the ratio of the Electricity production(% of total) of Peru in 1985 to that in 1986?
Your answer should be very brief. 1. What is the ratio of the Electricity production(% of total) of Uruguay in 1985 to that in 1986?
Provide a short and direct response. 0.99. What is the difference between the highest and the second highest Electricity production(% of total) of Arab World?
Offer a terse response. 1.91. What is the difference between the highest and the second highest Electricity production(% of total) of India?
Provide a succinct answer. 3.27. What is the difference between the highest and the second highest Electricity production(% of total) of Peru?
Ensure brevity in your answer.  0.23. What is the difference between the highest and the second highest Electricity production(% of total) in Uruguay?
Offer a terse response. 0.02. What is the difference between the highest and the lowest Electricity production(% of total) in Arab World?
Offer a terse response. 6.55. What is the difference between the highest and the lowest Electricity production(% of total) of India?
Your answer should be compact. 11.06. What is the difference between the highest and the lowest Electricity production(% of total) of Peru?
Offer a terse response. 3.71. What is the difference between the highest and the lowest Electricity production(% of total) in Uruguay?
Give a very brief answer. 19.37. 